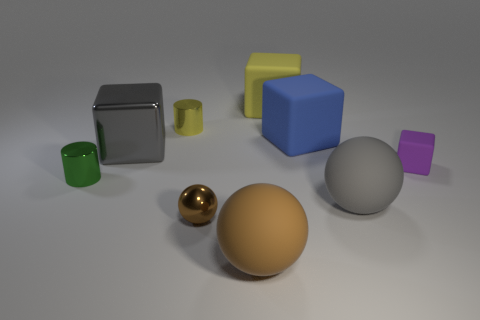The large gray object that is right of the gray shiny object has what shape?
Your response must be concise. Sphere. There is a large sphere that is in front of the rubber ball behind the large brown matte thing that is in front of the gray matte thing; what is it made of?
Your answer should be compact. Rubber. What number of other things are there of the same size as the gray matte ball?
Keep it short and to the point. 4. There is a blue object that is the same shape as the small purple thing; what material is it?
Make the answer very short. Rubber. What is the color of the small matte thing?
Make the answer very short. Purple. The tiny cylinder in front of the block on the left side of the tiny brown metallic thing is what color?
Ensure brevity in your answer.  Green. Does the large metal thing have the same color as the large rubber sphere that is behind the brown metallic object?
Give a very brief answer. Yes. How many metallic objects are on the left side of the big cube that is to the left of the tiny brown sphere that is to the right of the small yellow metal cylinder?
Your answer should be compact. 1. There is a brown metal ball; are there any gray objects to the left of it?
Make the answer very short. Yes. Is there anything else that has the same color as the large metallic thing?
Your response must be concise. Yes. 